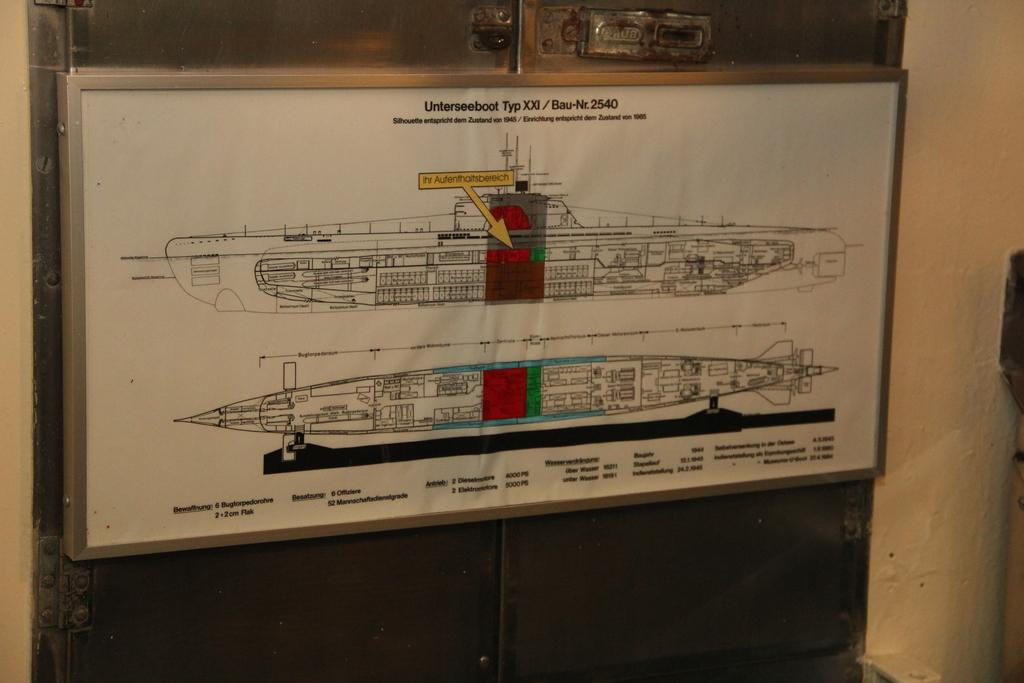What is the main object in the image? There is a white color board in the image. What can be seen on the color board? There are two sketches on the board and writing on the board. What type of smell can be detected from the color board in the image? There is no information about any smell in the image, as it only shows a white color board with sketches and writing. 